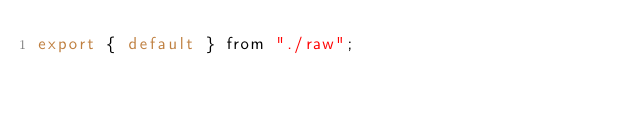Convert code to text. <code><loc_0><loc_0><loc_500><loc_500><_JavaScript_>export { default } from "./raw";
</code> 